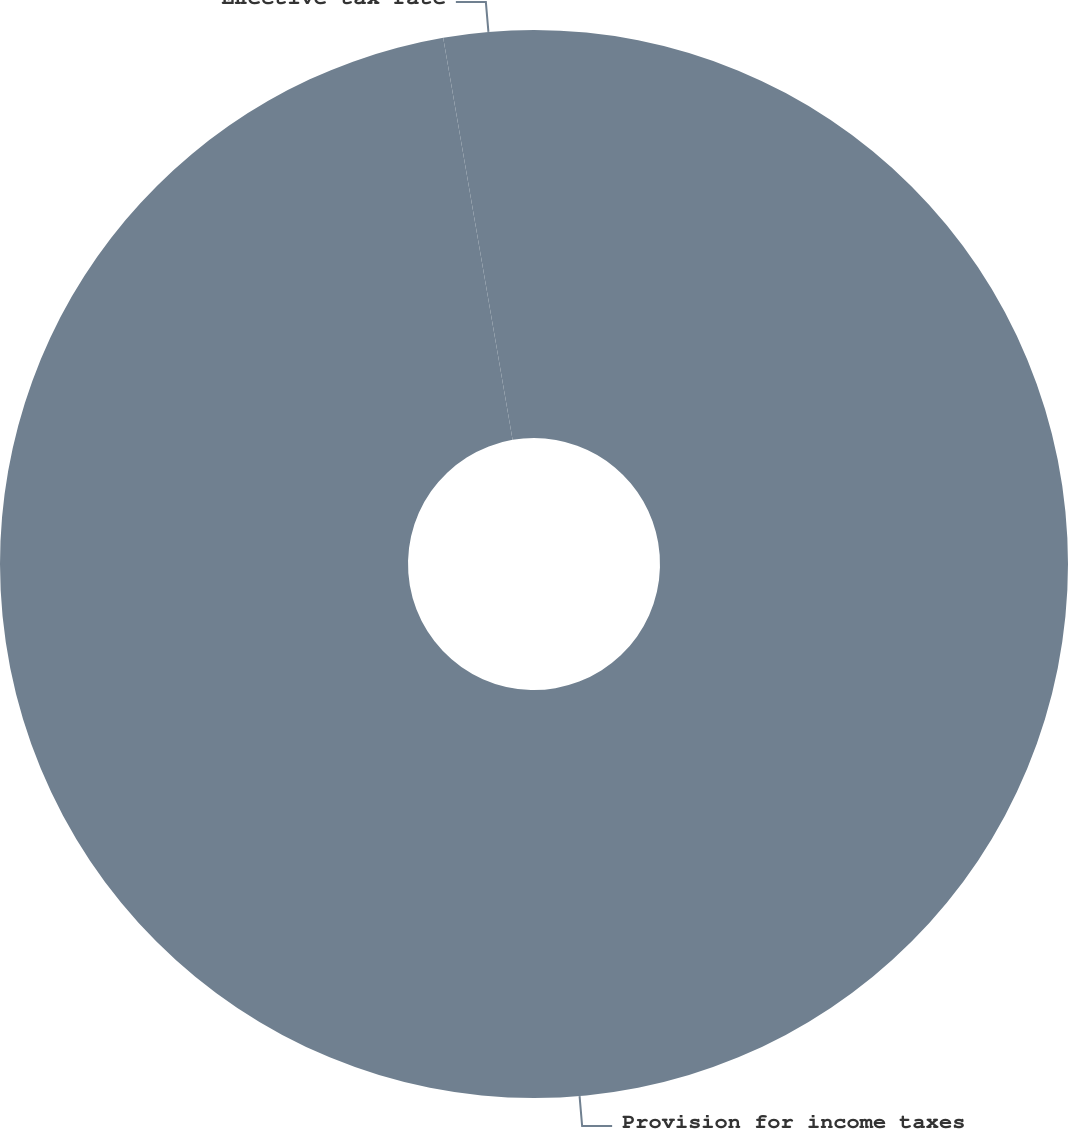Convert chart to OTSL. <chart><loc_0><loc_0><loc_500><loc_500><pie_chart><fcel>Provision for income taxes<fcel>Effective tax rate<nl><fcel>97.28%<fcel>2.72%<nl></chart> 